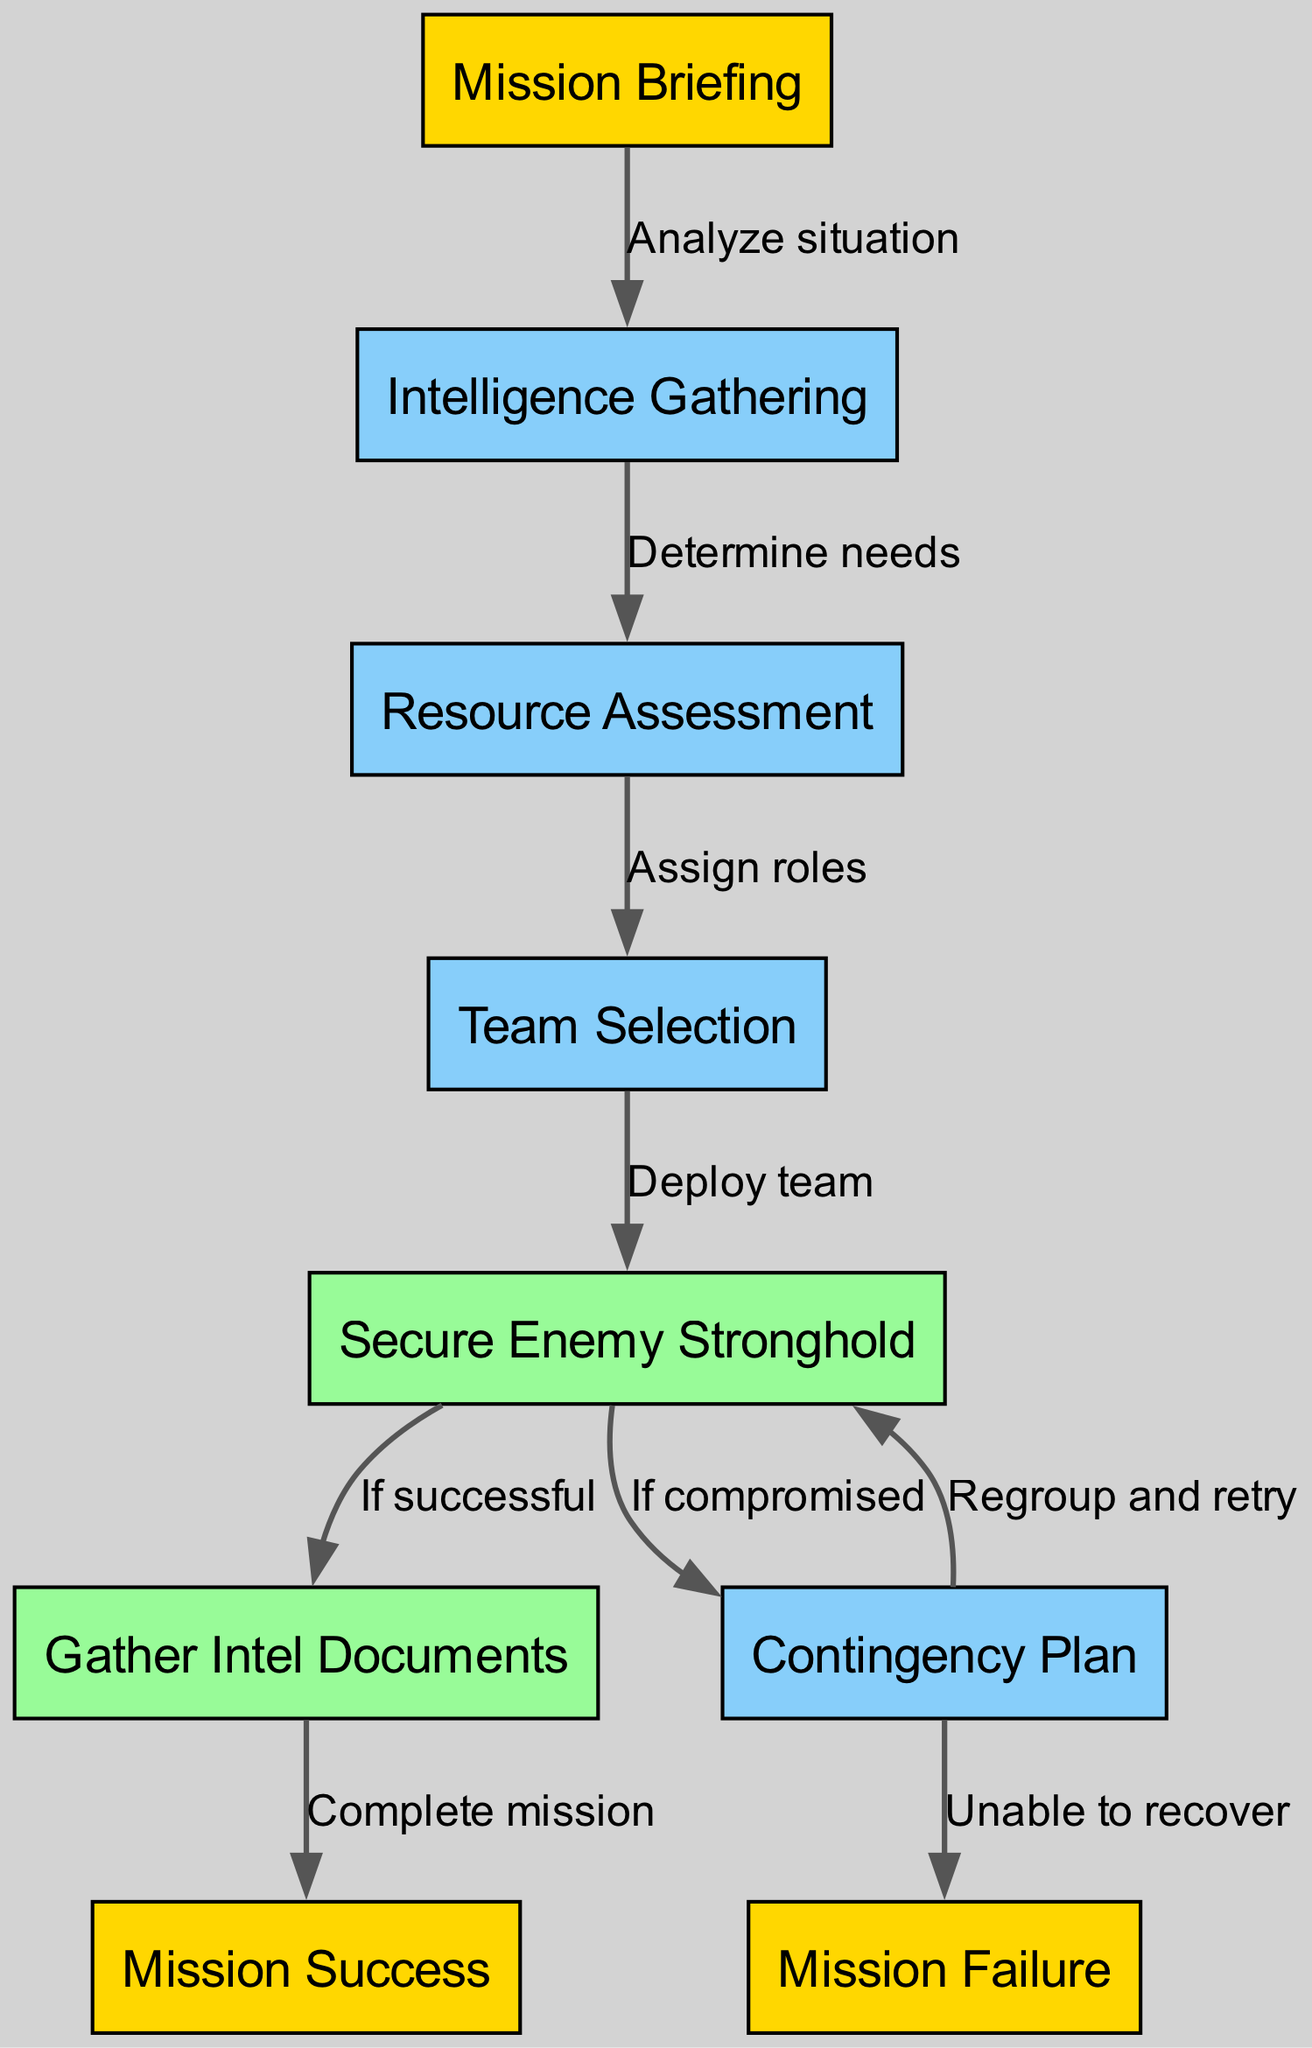What is the first step in the mission flowchart? The first step is "Mission Briefing," which is the initial action needed before proceeding to gather intelligence.
Answer: Mission Briefing How many nodes are present in the diagram? By counting the unique identifiers for each phase of the mission and the outcomes, there are a total of nine nodes in the diagram.
Answer: 9 What are the two potential outcomes from the primary objective? From the "Secure Enemy Stronghold" node, there are two possible outcomes: "Gather Intel Documents" if successful, and "Contingency Plan" if compromised.
Answer: Gather Intel Documents and Contingency Plan What action leads to mission success? The action that leads to "Mission Success" is completing the "Gather Intel Documents" objective after the primary objective is successfully achieved.
Answer: Complete mission What is the relationship between "Contingency Plan" and "Mission Failure"? The "Contingency Plan" leads to "Mission Failure" if the team is unable to recover from a compromised situation, showing a direct cause-effect link.
Answer: Unable to recover What is the label on the edge connecting "Team Selection" to "Primary Objective"? The label on the edge that connects these two nodes is "Deploy team," signifying the action taken after selecting the team for the mission.
Answer: Deploy team How does the flow proceed if the primary objective is compromised? If the primary objective is compromised, the flow indicates a need for a "Contingency Plan," directing the team towards alternative strategies for recovery.
Answer: Contingency Plan How many edges are in the diagram? By counting each directed connection between nodes, there are a total of eight edges representing the flow of actions and decisions.
Answer: 8 